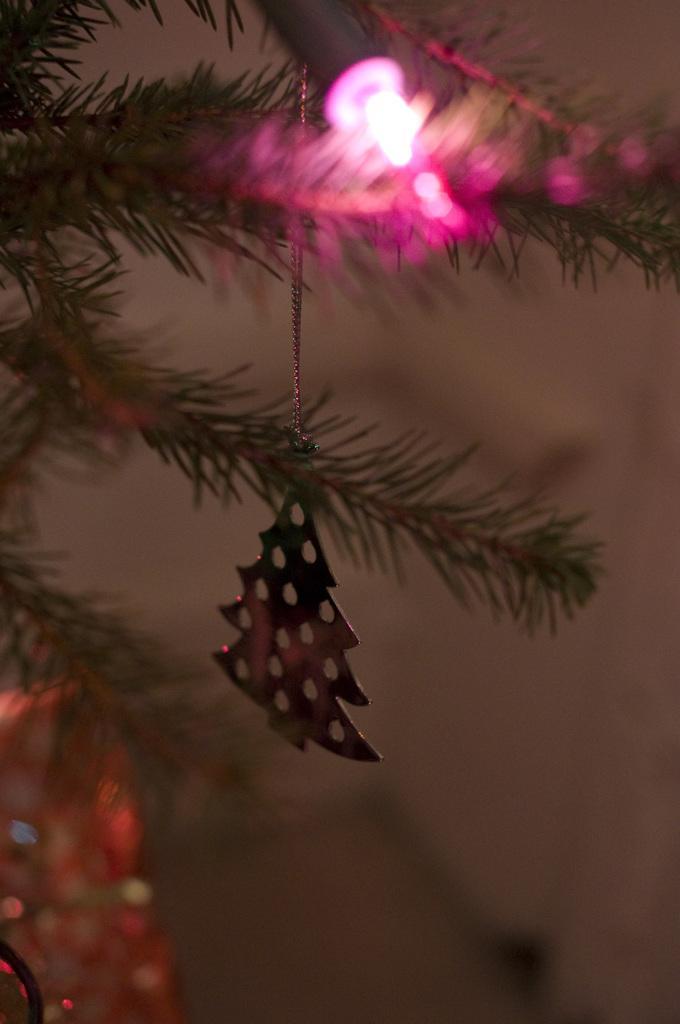Could you give a brief overview of what you see in this image? In this image I can see a christmas tree and to it I can see a pink colored light and few decorative items. I can see the blurry background. 